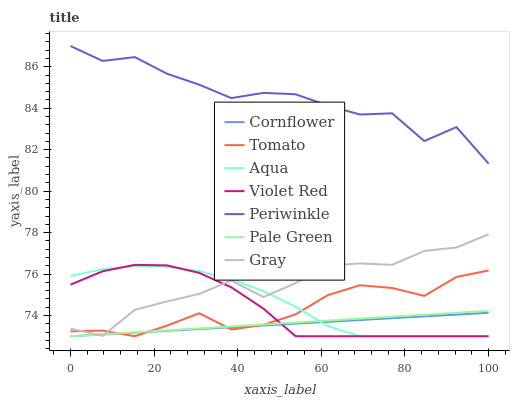Does Cornflower have the minimum area under the curve?
Answer yes or no. Yes. Does Periwinkle have the maximum area under the curve?
Answer yes or no. Yes. Does Violet Red have the minimum area under the curve?
Answer yes or no. No. Does Violet Red have the maximum area under the curve?
Answer yes or no. No. Is Cornflower the smoothest?
Answer yes or no. Yes. Is Periwinkle the roughest?
Answer yes or no. Yes. Is Violet Red the smoothest?
Answer yes or no. No. Is Violet Red the roughest?
Answer yes or no. No. Does Tomato have the lowest value?
Answer yes or no. Yes. Does Gray have the lowest value?
Answer yes or no. No. Does Periwinkle have the highest value?
Answer yes or no. Yes. Does Violet Red have the highest value?
Answer yes or no. No. Is Tomato less than Periwinkle?
Answer yes or no. Yes. Is Periwinkle greater than Tomato?
Answer yes or no. Yes. Does Cornflower intersect Pale Green?
Answer yes or no. Yes. Is Cornflower less than Pale Green?
Answer yes or no. No. Is Cornflower greater than Pale Green?
Answer yes or no. No. Does Tomato intersect Periwinkle?
Answer yes or no. No. 